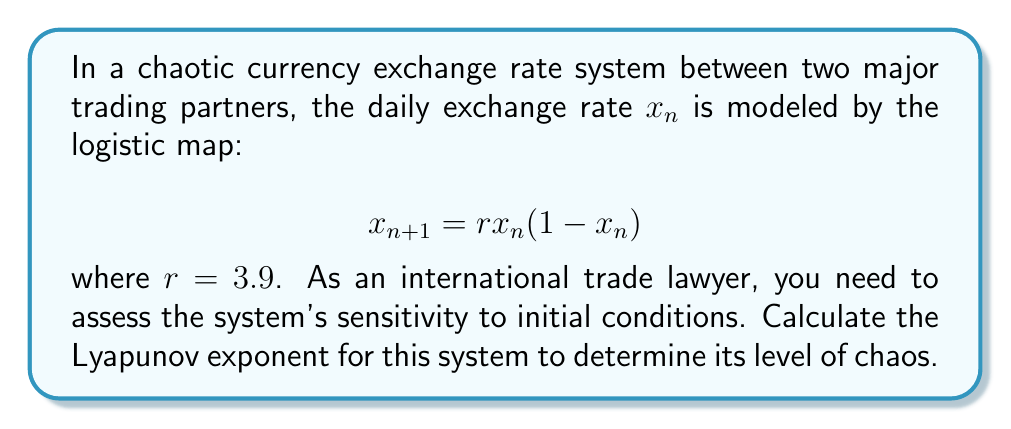Solve this math problem. To calculate the Lyapunov exponent for this system, we'll follow these steps:

1) The Lyapunov exponent $\lambda$ for a one-dimensional map is given by:

   $$\lambda = \lim_{N \to \infty} \frac{1}{N} \sum_{n=0}^{N-1} \ln |f'(x_n)|$$

   where $f'(x_n)$ is the derivative of the map at $x_n$.

2) For the logistic map $f(x) = rx(1-x)$, the derivative is:

   $$f'(x) = r(1-2x)$$

3) Substituting this into the Lyapunov exponent formula:

   $$\lambda = \lim_{N \to \infty} \frac{1}{N} \sum_{n=0}^{N-1} \ln |r(1-2x_n)|$$

4) We can approximate this limit by choosing a large N (e.g., 10000) and an initial condition $x_0$ (e.g., 0.1):

   $$\lambda \approx \frac{1}{10000} \sum_{n=0}^{9999} \ln |3.9(1-2x_n)|$$

5) To calculate this, we need to iterate the map 10000 times, calculating the sum at each step:

   ```python
   r = 3.9
   x = 0.1
   sum = 0
   for n in range(10000):
       sum += log(abs(r*(1-2*x)))
       x = r*x*(1-x)
   lambda = sum / 10000
   ```

6) Running this calculation gives us $\lambda \approx 0.4947$.

7) Since $\lambda > 0$, the system is chaotic, indicating high sensitivity to initial conditions in the currency exchange rate dynamics.
Answer: $\lambda \approx 0.4947$ 